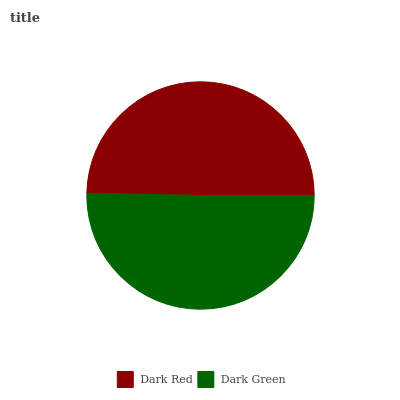Is Dark Red the minimum?
Answer yes or no. Yes. Is Dark Green the maximum?
Answer yes or no. Yes. Is Dark Green the minimum?
Answer yes or no. No. Is Dark Green greater than Dark Red?
Answer yes or no. Yes. Is Dark Red less than Dark Green?
Answer yes or no. Yes. Is Dark Red greater than Dark Green?
Answer yes or no. No. Is Dark Green less than Dark Red?
Answer yes or no. No. Is Dark Green the high median?
Answer yes or no. Yes. Is Dark Red the low median?
Answer yes or no. Yes. Is Dark Red the high median?
Answer yes or no. No. Is Dark Green the low median?
Answer yes or no. No. 